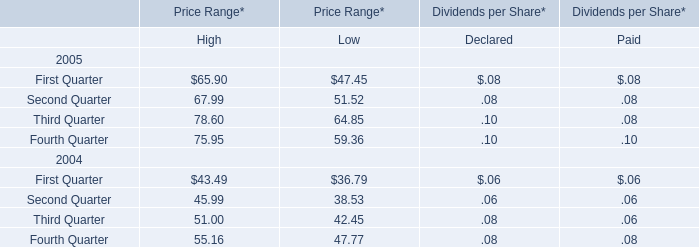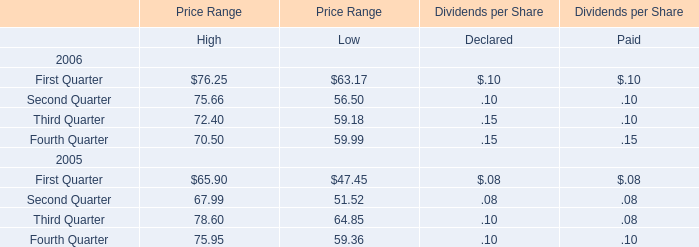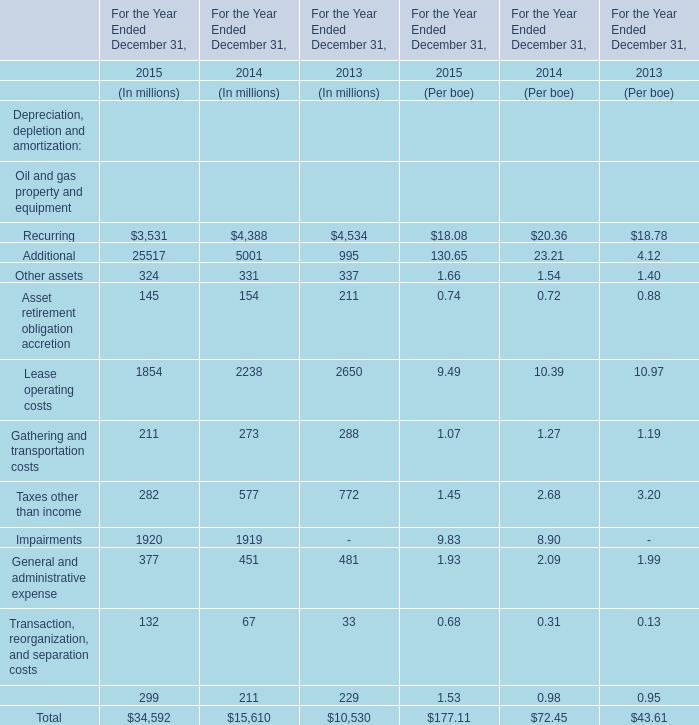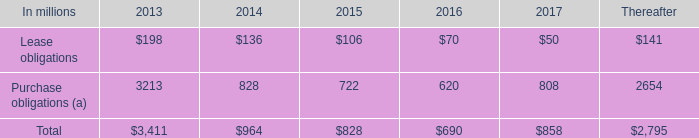In the year with lowest amount of Other assets in table 2, what's the increasing rate of Recurring in table 2? 
Computations: ((3531 - 4388) / 4388)
Answer: -0.19531. 